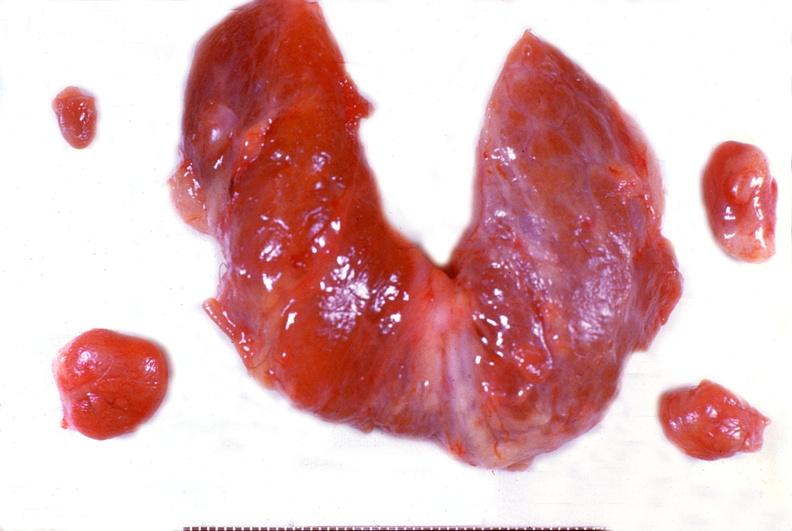s endocrine present?
Answer the question using a single word or phrase. Yes 